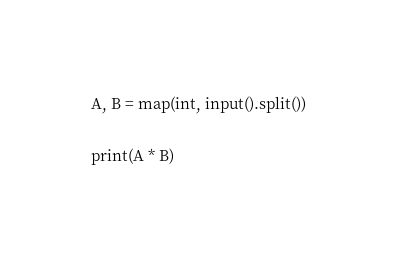<code> <loc_0><loc_0><loc_500><loc_500><_Python_>A, B = map(int, input().split())

print(A * B)</code> 